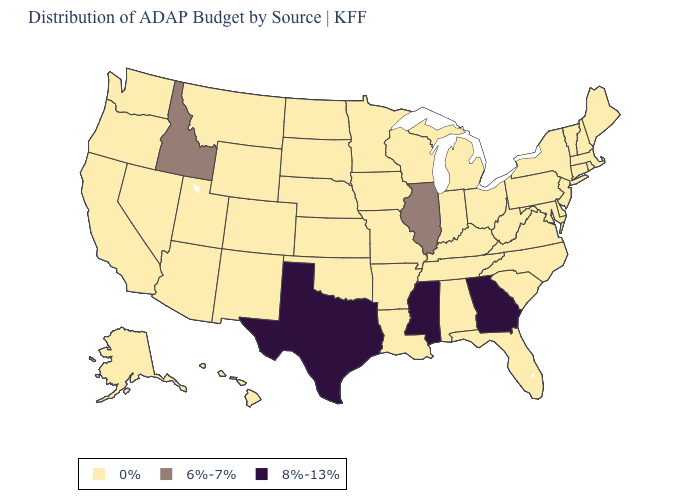Which states have the lowest value in the USA?
Write a very short answer. Alabama, Alaska, Arizona, Arkansas, California, Colorado, Connecticut, Delaware, Florida, Hawaii, Indiana, Iowa, Kansas, Kentucky, Louisiana, Maine, Maryland, Massachusetts, Michigan, Minnesota, Missouri, Montana, Nebraska, Nevada, New Hampshire, New Jersey, New Mexico, New York, North Carolina, North Dakota, Ohio, Oklahoma, Oregon, Pennsylvania, Rhode Island, South Carolina, South Dakota, Tennessee, Utah, Vermont, Virginia, Washington, West Virginia, Wisconsin, Wyoming. Among the states that border Nevada , which have the lowest value?
Answer briefly. Arizona, California, Oregon, Utah. What is the value of Vermont?
Keep it brief. 0%. Does Tennessee have the same value as Georgia?
Short answer required. No. Does the map have missing data?
Keep it brief. No. What is the value of Oklahoma?
Write a very short answer. 0%. What is the value of New Hampshire?
Short answer required. 0%. Which states have the highest value in the USA?
Quick response, please. Georgia, Mississippi, Texas. Name the states that have a value in the range 6%-7%?
Short answer required. Idaho, Illinois. Name the states that have a value in the range 8%-13%?
Answer briefly. Georgia, Mississippi, Texas. What is the highest value in the USA?
Write a very short answer. 8%-13%. Name the states that have a value in the range 8%-13%?
Quick response, please. Georgia, Mississippi, Texas. What is the value of Rhode Island?
Short answer required. 0%. Does New York have the highest value in the USA?
Quick response, please. No. 